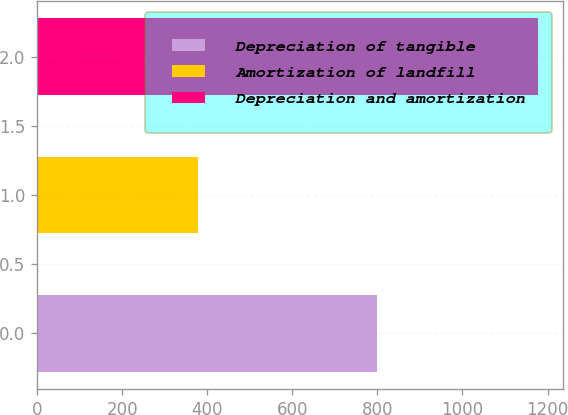<chart> <loc_0><loc_0><loc_500><loc_500><bar_chart><fcel>Depreciation of tangible<fcel>Amortization of landfill<fcel>Depreciation and amortization<nl><fcel>800<fcel>378<fcel>1178<nl></chart> 